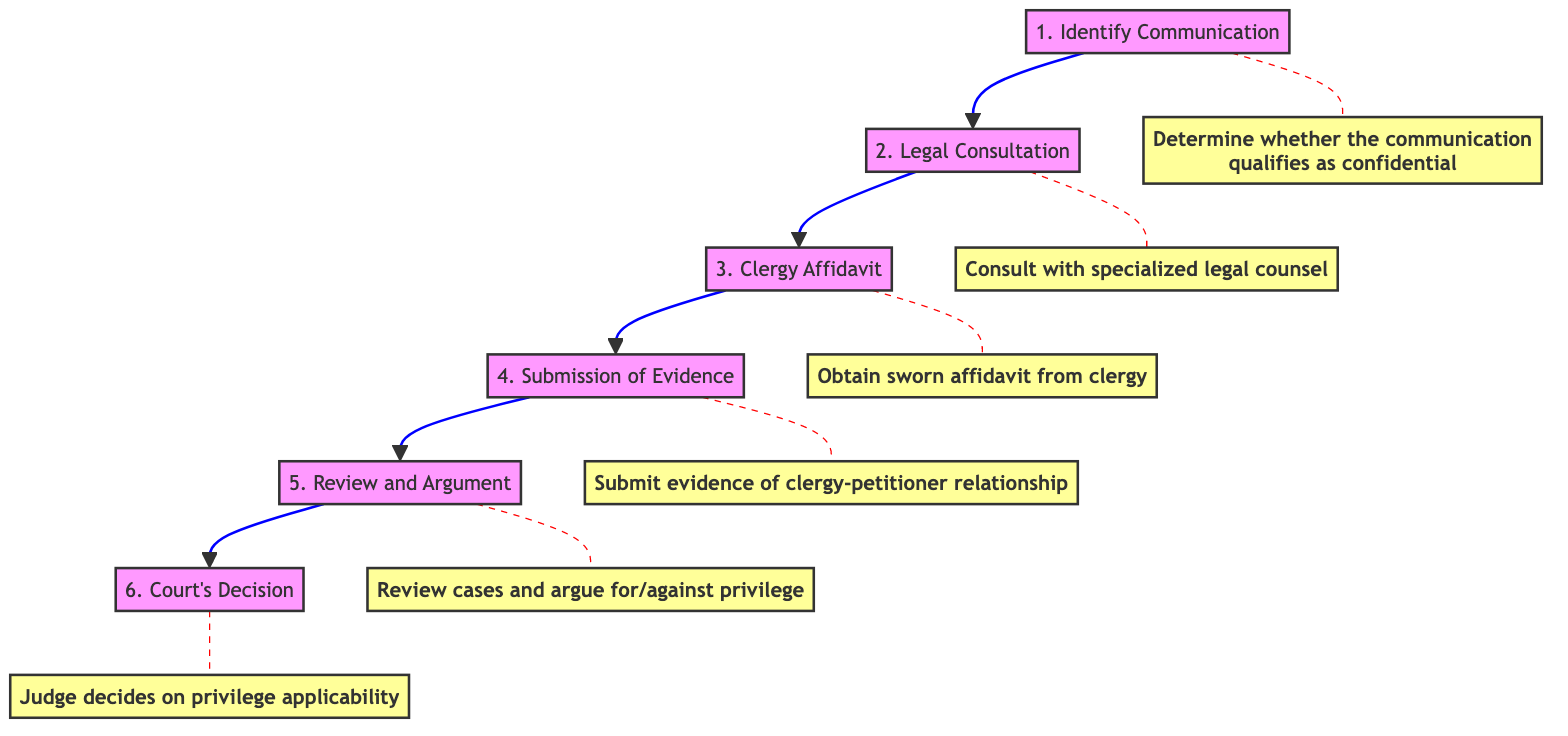What is the first step in the process? The first step in the process is identified by the node at the bottom of the diagram, labeled "Identify Communication." This is the starting point of the flow.
Answer: Identify Communication How many total steps are there in the diagram? By counting the steps represented in the diagram from the bottom to the top, there are six individual steps displayed.
Answer: 6 What comes immediately after "Legal Consultation"? In the flow order from bottom to up, the step that follows "Legal Consultation" is "Clergy Affidavit," making it the next action in the sequence.
Answer: Clergy Affidavit What is the focus of the affidavit according to step three? The third step's description tells us that it is about obtaining a sworn affidavit from the clergy member, which emphasizes the confidentiality of communication.
Answer: Confidential nature of the communication What does the court do at step six? According to the last step in the diagram, the judge's role is to review the collected evidence and determines whether the clergy-penitent privilege is applicable, thus making a legal decision.
Answer: Judge decides on privilege applicability What step involves evidence submission? The fourth step in the flow clearly indicates that it is the "Submission of Evidence," which is necessary to support the claim of clergy-penitent privilege.
Answer: Submission of Evidence What action should be taken after obtaining the clergy affidavit? Following the clergy affidavit step, the next required action is detailed in step four, which is the submission of evidence demonstrating the communication's context.
Answer: Submission of Evidence What is the goal of the review and argument step? Step five describes that the intent of this stage is to review prior cases and statutory laws, facilitating arguments for or against recognizing the privilege during the court proceedings.
Answer: Argue for or against the recognition of the privilege 